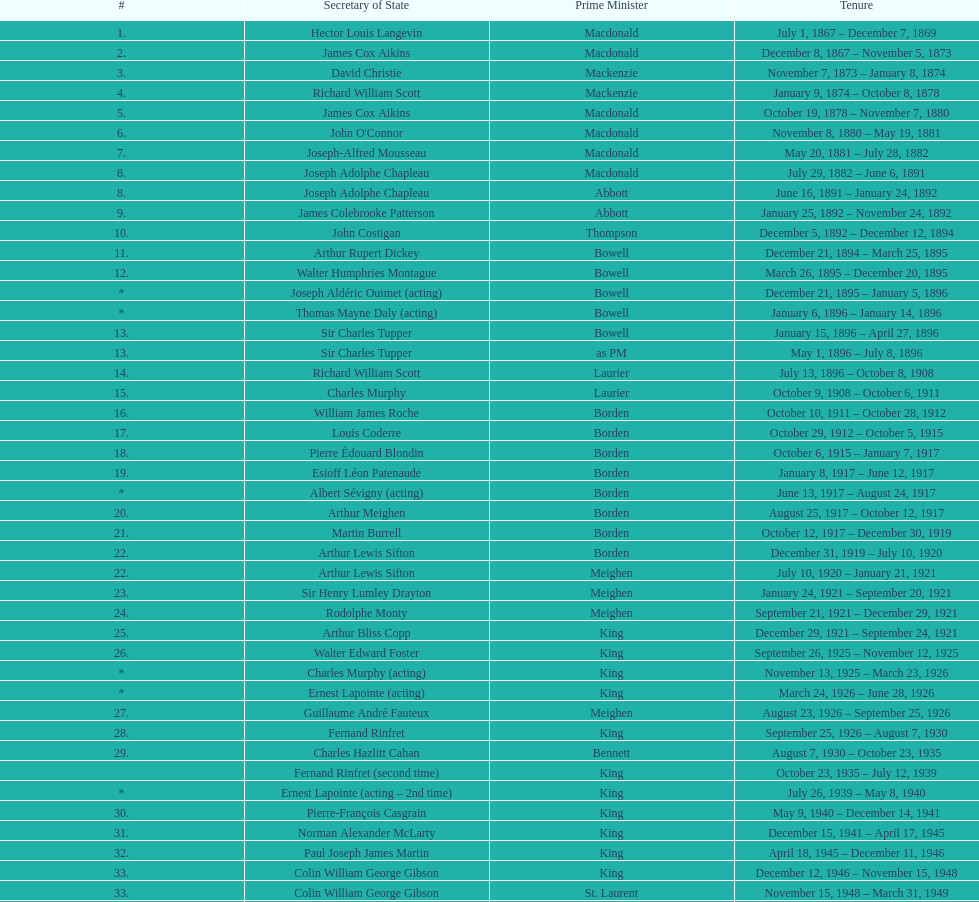How many secretary of states were under prime minister macdonald? 6. 